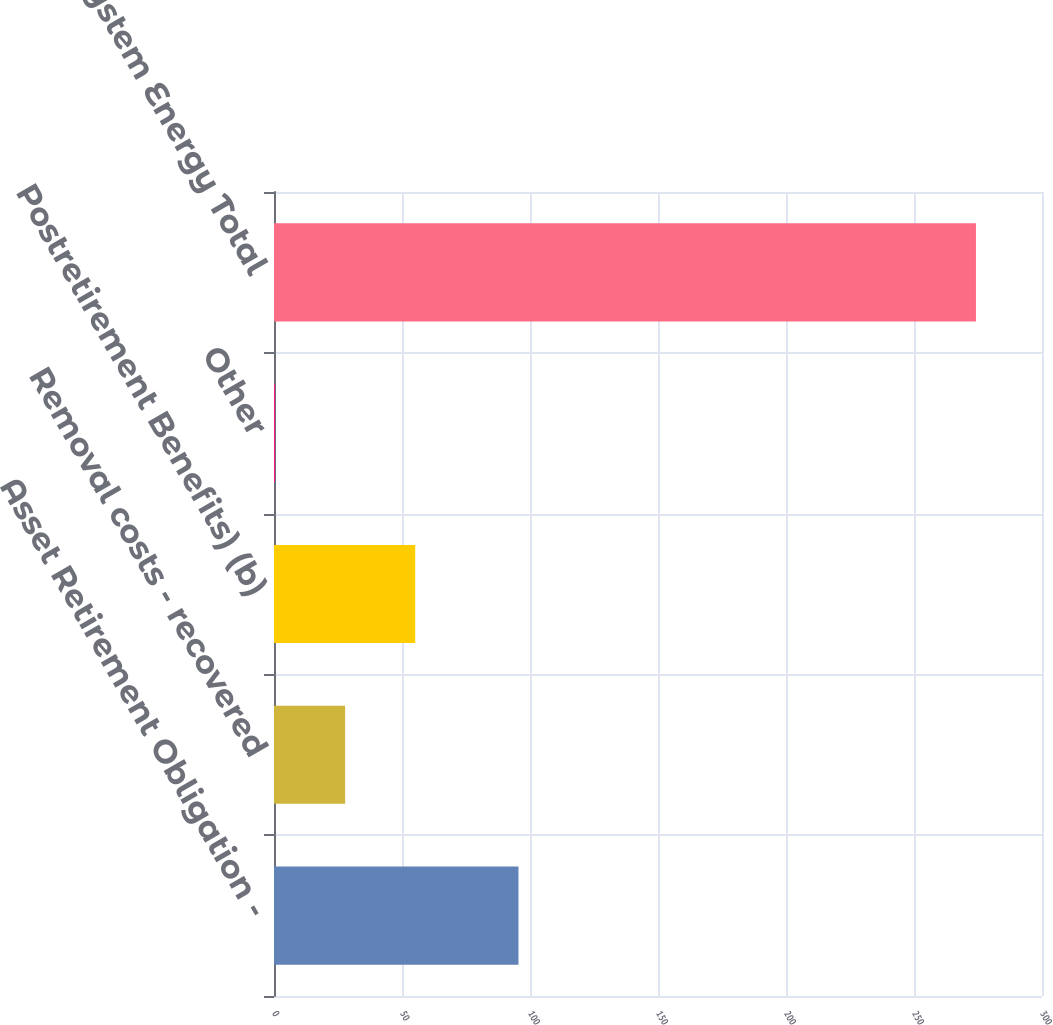Convert chart. <chart><loc_0><loc_0><loc_500><loc_500><bar_chart><fcel>Asset Retirement Obligation -<fcel>Removal costs - recovered<fcel>Postretirement Benefits) (b)<fcel>Other<fcel>System Energy Total<nl><fcel>95.5<fcel>27.78<fcel>55.16<fcel>0.4<fcel>274.2<nl></chart> 